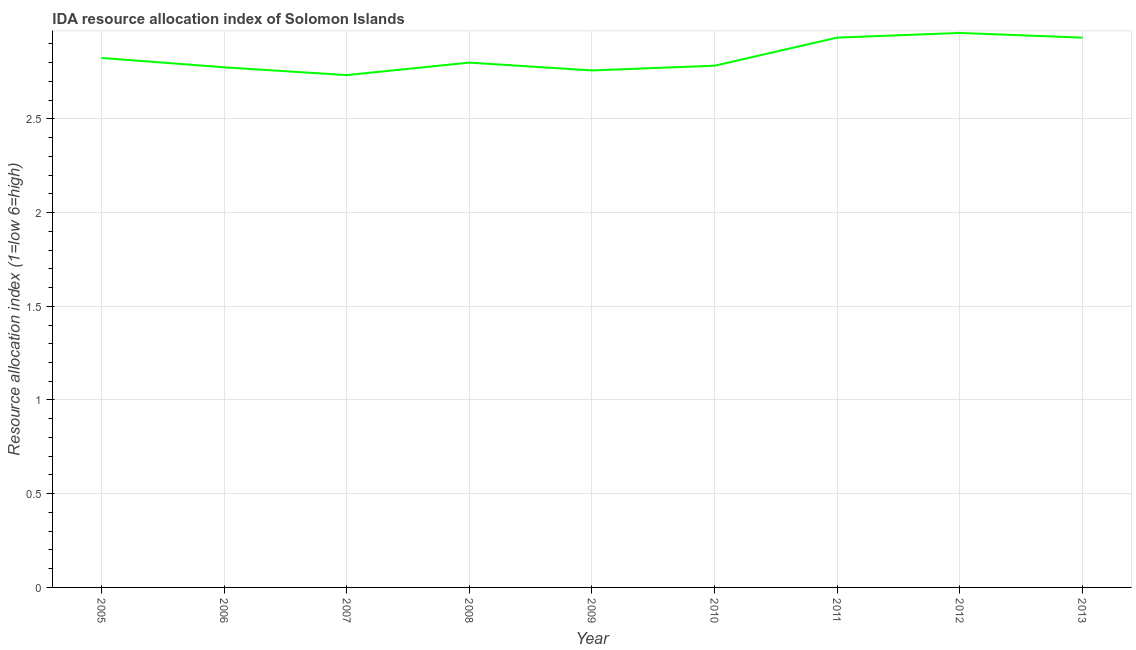Across all years, what is the maximum ida resource allocation index?
Give a very brief answer. 2.96. Across all years, what is the minimum ida resource allocation index?
Your response must be concise. 2.73. In which year was the ida resource allocation index maximum?
Your answer should be compact. 2012. What is the sum of the ida resource allocation index?
Your response must be concise. 25.5. What is the difference between the ida resource allocation index in 2008 and 2010?
Give a very brief answer. 0.02. What is the average ida resource allocation index per year?
Your answer should be compact. 2.83. What is the median ida resource allocation index?
Ensure brevity in your answer.  2.8. In how many years, is the ida resource allocation index greater than 1.2 ?
Your answer should be compact. 9. Do a majority of the years between 2009 and 2006 (inclusive) have ida resource allocation index greater than 2.5 ?
Give a very brief answer. Yes. What is the ratio of the ida resource allocation index in 2006 to that in 2009?
Your answer should be very brief. 1.01. Is the ida resource allocation index in 2007 less than that in 2011?
Your answer should be very brief. Yes. What is the difference between the highest and the second highest ida resource allocation index?
Provide a short and direct response. 0.02. Is the sum of the ida resource allocation index in 2009 and 2011 greater than the maximum ida resource allocation index across all years?
Your answer should be compact. Yes. What is the difference between the highest and the lowest ida resource allocation index?
Keep it short and to the point. 0.23. How many lines are there?
Offer a terse response. 1. What is the title of the graph?
Offer a very short reply. IDA resource allocation index of Solomon Islands. What is the label or title of the Y-axis?
Your answer should be compact. Resource allocation index (1=low 6=high). What is the Resource allocation index (1=low 6=high) in 2005?
Make the answer very short. 2.83. What is the Resource allocation index (1=low 6=high) in 2006?
Make the answer very short. 2.77. What is the Resource allocation index (1=low 6=high) of 2007?
Ensure brevity in your answer.  2.73. What is the Resource allocation index (1=low 6=high) of 2009?
Give a very brief answer. 2.76. What is the Resource allocation index (1=low 6=high) in 2010?
Keep it short and to the point. 2.78. What is the Resource allocation index (1=low 6=high) in 2011?
Make the answer very short. 2.93. What is the Resource allocation index (1=low 6=high) of 2012?
Give a very brief answer. 2.96. What is the Resource allocation index (1=low 6=high) of 2013?
Provide a short and direct response. 2.93. What is the difference between the Resource allocation index (1=low 6=high) in 2005 and 2007?
Keep it short and to the point. 0.09. What is the difference between the Resource allocation index (1=low 6=high) in 2005 and 2008?
Keep it short and to the point. 0.03. What is the difference between the Resource allocation index (1=low 6=high) in 2005 and 2009?
Your answer should be compact. 0.07. What is the difference between the Resource allocation index (1=low 6=high) in 2005 and 2010?
Offer a very short reply. 0.04. What is the difference between the Resource allocation index (1=low 6=high) in 2005 and 2011?
Ensure brevity in your answer.  -0.11. What is the difference between the Resource allocation index (1=low 6=high) in 2005 and 2012?
Your answer should be compact. -0.13. What is the difference between the Resource allocation index (1=low 6=high) in 2005 and 2013?
Make the answer very short. -0.11. What is the difference between the Resource allocation index (1=low 6=high) in 2006 and 2007?
Your answer should be compact. 0.04. What is the difference between the Resource allocation index (1=low 6=high) in 2006 and 2008?
Ensure brevity in your answer.  -0.03. What is the difference between the Resource allocation index (1=low 6=high) in 2006 and 2009?
Make the answer very short. 0.02. What is the difference between the Resource allocation index (1=low 6=high) in 2006 and 2010?
Your answer should be compact. -0.01. What is the difference between the Resource allocation index (1=low 6=high) in 2006 and 2011?
Ensure brevity in your answer.  -0.16. What is the difference between the Resource allocation index (1=low 6=high) in 2006 and 2012?
Provide a succinct answer. -0.18. What is the difference between the Resource allocation index (1=low 6=high) in 2006 and 2013?
Provide a short and direct response. -0.16. What is the difference between the Resource allocation index (1=low 6=high) in 2007 and 2008?
Provide a succinct answer. -0.07. What is the difference between the Resource allocation index (1=low 6=high) in 2007 and 2009?
Keep it short and to the point. -0.03. What is the difference between the Resource allocation index (1=low 6=high) in 2007 and 2010?
Give a very brief answer. -0.05. What is the difference between the Resource allocation index (1=low 6=high) in 2007 and 2011?
Your answer should be compact. -0.2. What is the difference between the Resource allocation index (1=low 6=high) in 2007 and 2012?
Your answer should be very brief. -0.23. What is the difference between the Resource allocation index (1=low 6=high) in 2008 and 2009?
Provide a succinct answer. 0.04. What is the difference between the Resource allocation index (1=low 6=high) in 2008 and 2010?
Give a very brief answer. 0.02. What is the difference between the Resource allocation index (1=low 6=high) in 2008 and 2011?
Provide a short and direct response. -0.13. What is the difference between the Resource allocation index (1=low 6=high) in 2008 and 2012?
Offer a very short reply. -0.16. What is the difference between the Resource allocation index (1=low 6=high) in 2008 and 2013?
Give a very brief answer. -0.13. What is the difference between the Resource allocation index (1=low 6=high) in 2009 and 2010?
Make the answer very short. -0.03. What is the difference between the Resource allocation index (1=low 6=high) in 2009 and 2011?
Provide a short and direct response. -0.17. What is the difference between the Resource allocation index (1=low 6=high) in 2009 and 2012?
Ensure brevity in your answer.  -0.2. What is the difference between the Resource allocation index (1=low 6=high) in 2009 and 2013?
Provide a short and direct response. -0.17. What is the difference between the Resource allocation index (1=low 6=high) in 2010 and 2012?
Your answer should be compact. -0.17. What is the difference between the Resource allocation index (1=low 6=high) in 2011 and 2012?
Keep it short and to the point. -0.03. What is the difference between the Resource allocation index (1=low 6=high) in 2011 and 2013?
Your answer should be very brief. 0. What is the difference between the Resource allocation index (1=low 6=high) in 2012 and 2013?
Make the answer very short. 0.03. What is the ratio of the Resource allocation index (1=low 6=high) in 2005 to that in 2006?
Provide a short and direct response. 1.02. What is the ratio of the Resource allocation index (1=low 6=high) in 2005 to that in 2007?
Ensure brevity in your answer.  1.03. What is the ratio of the Resource allocation index (1=low 6=high) in 2005 to that in 2008?
Your answer should be very brief. 1.01. What is the ratio of the Resource allocation index (1=low 6=high) in 2005 to that in 2012?
Offer a terse response. 0.95. What is the ratio of the Resource allocation index (1=low 6=high) in 2006 to that in 2007?
Provide a succinct answer. 1.01. What is the ratio of the Resource allocation index (1=low 6=high) in 2006 to that in 2008?
Give a very brief answer. 0.99. What is the ratio of the Resource allocation index (1=low 6=high) in 2006 to that in 2009?
Your answer should be compact. 1.01. What is the ratio of the Resource allocation index (1=low 6=high) in 2006 to that in 2011?
Your response must be concise. 0.95. What is the ratio of the Resource allocation index (1=low 6=high) in 2006 to that in 2012?
Keep it short and to the point. 0.94. What is the ratio of the Resource allocation index (1=low 6=high) in 2006 to that in 2013?
Provide a short and direct response. 0.95. What is the ratio of the Resource allocation index (1=low 6=high) in 2007 to that in 2009?
Ensure brevity in your answer.  0.99. What is the ratio of the Resource allocation index (1=low 6=high) in 2007 to that in 2010?
Keep it short and to the point. 0.98. What is the ratio of the Resource allocation index (1=low 6=high) in 2007 to that in 2011?
Your answer should be compact. 0.93. What is the ratio of the Resource allocation index (1=low 6=high) in 2007 to that in 2012?
Your response must be concise. 0.92. What is the ratio of the Resource allocation index (1=low 6=high) in 2007 to that in 2013?
Your response must be concise. 0.93. What is the ratio of the Resource allocation index (1=low 6=high) in 2008 to that in 2010?
Keep it short and to the point. 1.01. What is the ratio of the Resource allocation index (1=low 6=high) in 2008 to that in 2011?
Your response must be concise. 0.95. What is the ratio of the Resource allocation index (1=low 6=high) in 2008 to that in 2012?
Your response must be concise. 0.95. What is the ratio of the Resource allocation index (1=low 6=high) in 2008 to that in 2013?
Offer a very short reply. 0.95. What is the ratio of the Resource allocation index (1=low 6=high) in 2009 to that in 2010?
Your response must be concise. 0.99. What is the ratio of the Resource allocation index (1=low 6=high) in 2009 to that in 2011?
Offer a very short reply. 0.94. What is the ratio of the Resource allocation index (1=low 6=high) in 2009 to that in 2012?
Keep it short and to the point. 0.93. What is the ratio of the Resource allocation index (1=low 6=high) in 2010 to that in 2011?
Your answer should be compact. 0.95. What is the ratio of the Resource allocation index (1=low 6=high) in 2010 to that in 2012?
Your answer should be very brief. 0.94. What is the ratio of the Resource allocation index (1=low 6=high) in 2010 to that in 2013?
Give a very brief answer. 0.95. What is the ratio of the Resource allocation index (1=low 6=high) in 2011 to that in 2012?
Provide a short and direct response. 0.99. What is the ratio of the Resource allocation index (1=low 6=high) in 2011 to that in 2013?
Ensure brevity in your answer.  1. 